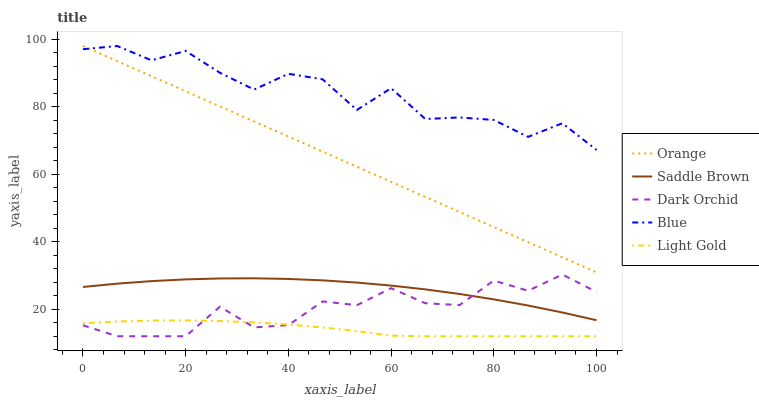Does Blue have the minimum area under the curve?
Answer yes or no. No. Does Light Gold have the maximum area under the curve?
Answer yes or no. No. Is Light Gold the smoothest?
Answer yes or no. No. Is Light Gold the roughest?
Answer yes or no. No. Does Blue have the lowest value?
Answer yes or no. No. Does Light Gold have the highest value?
Answer yes or no. No. Is Light Gold less than Saddle Brown?
Answer yes or no. Yes. Is Saddle Brown greater than Light Gold?
Answer yes or no. Yes. Does Light Gold intersect Saddle Brown?
Answer yes or no. No. 